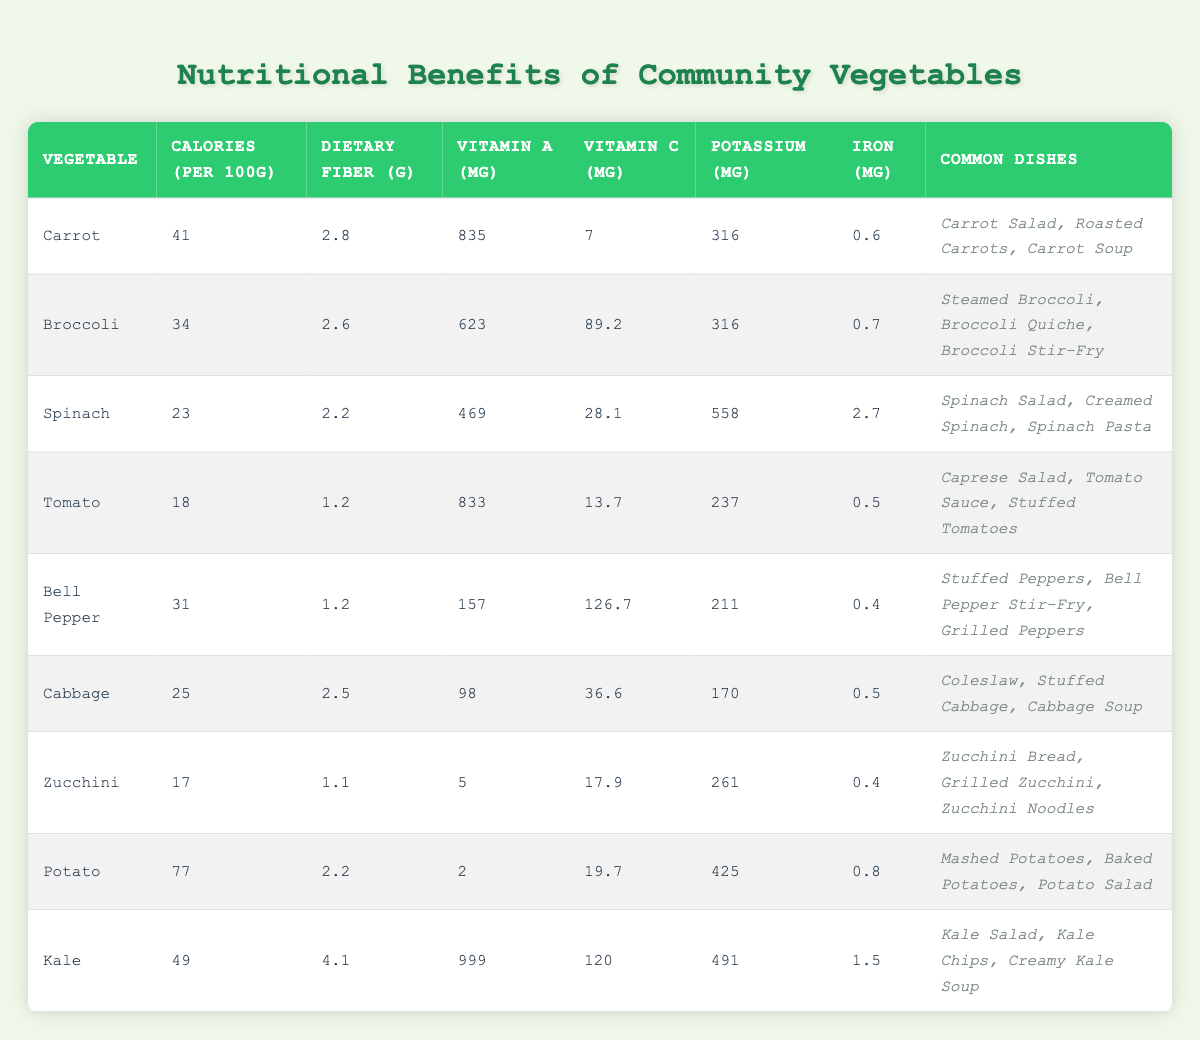What is the vegetable with the highest Vitamin A content? Looking at the table, Kale has 999 μg of Vitamin A, which is higher than all other vegetables listed.
Answer: Kale Which vegetable has the lowest calorie content per 100g? The table shows that Zucchini has the lowest calorie content at 17 calories per 100g.
Answer: Zucchini What is the average dietary fiber content of the vegetables in the table? To find the average, add the dietary fiber values (2.8 + 2.6 + 2.2 + 1.2 + 1.2 + 2.5 + 1.1 + 2.2 + 4.1) = 19.9. There are 9 vegetables, thus the average is 19.9 / 9 ≈ 2.21 g.
Answer: 2.21 g Is the iron content in Spinach higher than that in Tomatos? Spinach has 2.7 mg of iron and Tomatoes have 0.5 mg of iron. Since 2.7 > 0.5, the statement is true.
Answer: Yes What are the common dishes that include Bell Peppers? The table lists the common dishes as Stuffed Peppers, Bell Pepper Stir-Fry, and Grilled Peppers.
Answer: Stuffed Peppers, Bell Pepper Stir-Fry, Grilled Peppers What is the difference in Vitamin C content between Broccoli and Potato? Broccoli has 89.2 mg of Vitamin C, while Potato has 19.7 mg. The difference is 89.2 - 19.7 = 69.5 mg.
Answer: 69.5 mg Which vegetable has both the highest Vitamin C and the highest Dietary Fiber content? Examining the table, Bell Pepper has the highest Vitamin C at 126.7 mg, while Kale has the highest dietary fiber at 4.1 g. No single vegetable has both, so the answer is none.
Answer: None How many vegetables have more than 30 mg of Vitamin C per 100g? From the table, Broccoli (89.2), Bell Pepper (126.7), and Kale (120) all exceed 30 mg of Vitamin C. Thus, there are 3 vegetables.
Answer: 3 What is the potassium content of the vegetable with the lowest calories? The vegetable with the lowest calories is Zucchini (17 calories) which contains 261 mg of potassium.
Answer: 261 mg If you wanted to prepare a dish with the highest accumulation of Vitamin A across 100g servings, which vegetable would you choose? The highest Vitamin A content is in Kale (999 μg), so it should be the chosen vegetable for the highest accumulation.
Answer: Kale 